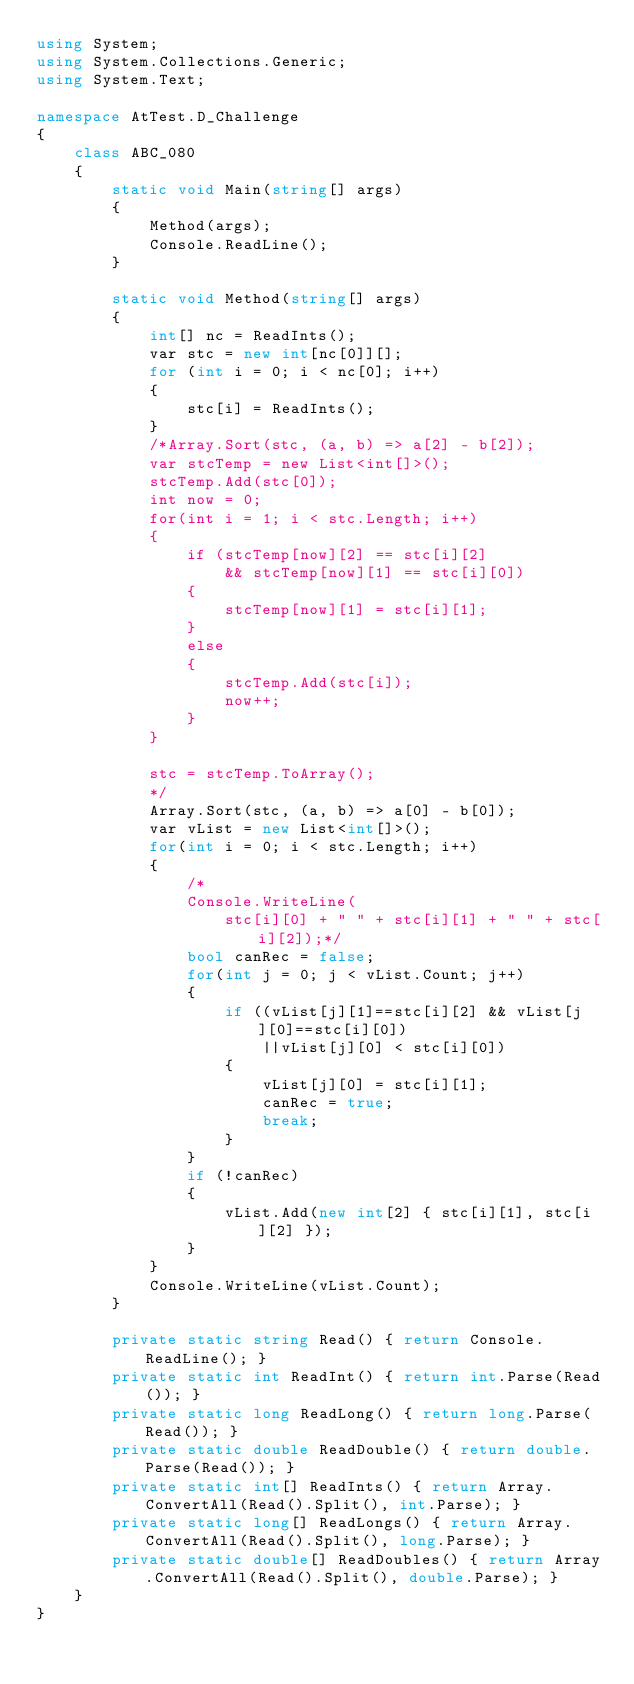Convert code to text. <code><loc_0><loc_0><loc_500><loc_500><_C#_>using System;
using System.Collections.Generic;
using System.Text;

namespace AtTest.D_Challenge
{
    class ABC_080
    {
        static void Main(string[] args)
        {
            Method(args);
            Console.ReadLine();
        }

        static void Method(string[] args)
        {
            int[] nc = ReadInts();
            var stc = new int[nc[0]][];
            for (int i = 0; i < nc[0]; i++)
            {
                stc[i] = ReadInts();
            }
            /*Array.Sort(stc, (a, b) => a[2] - b[2]);
            var stcTemp = new List<int[]>();
            stcTemp.Add(stc[0]);
            int now = 0;
            for(int i = 1; i < stc.Length; i++)
            {
                if (stcTemp[now][2] == stc[i][2]
                    && stcTemp[now][1] == stc[i][0])
                {
                    stcTemp[now][1] = stc[i][1];
                }
                else
                {
                    stcTemp.Add(stc[i]);
                    now++;
                }
            }

            stc = stcTemp.ToArray();
            */
            Array.Sort(stc, (a, b) => a[0] - b[0]);
            var vList = new List<int[]>();
            for(int i = 0; i < stc.Length; i++)
            {
                /*
                Console.WriteLine(
                    stc[i][0] + " " + stc[i][1] + " " + stc[i][2]);*/
                bool canRec = false;
                for(int j = 0; j < vList.Count; j++)
                {
                    if ((vList[j][1]==stc[i][2] && vList[j][0]==stc[i][0])
                        ||vList[j][0] < stc[i][0])
                    {
                        vList[j][0] = stc[i][1];
                        canRec = true;
                        break;
                    }
                }
                if (!canRec)
                {
                    vList.Add(new int[2] { stc[i][1], stc[i][2] });
                }
            }
            Console.WriteLine(vList.Count);
        }

        private static string Read() { return Console.ReadLine(); }
        private static int ReadInt() { return int.Parse(Read()); }
        private static long ReadLong() { return long.Parse(Read()); }
        private static double ReadDouble() { return double.Parse(Read()); }
        private static int[] ReadInts() { return Array.ConvertAll(Read().Split(), int.Parse); }
        private static long[] ReadLongs() { return Array.ConvertAll(Read().Split(), long.Parse); }
        private static double[] ReadDoubles() { return Array.ConvertAll(Read().Split(), double.Parse); }
    }
}
</code> 